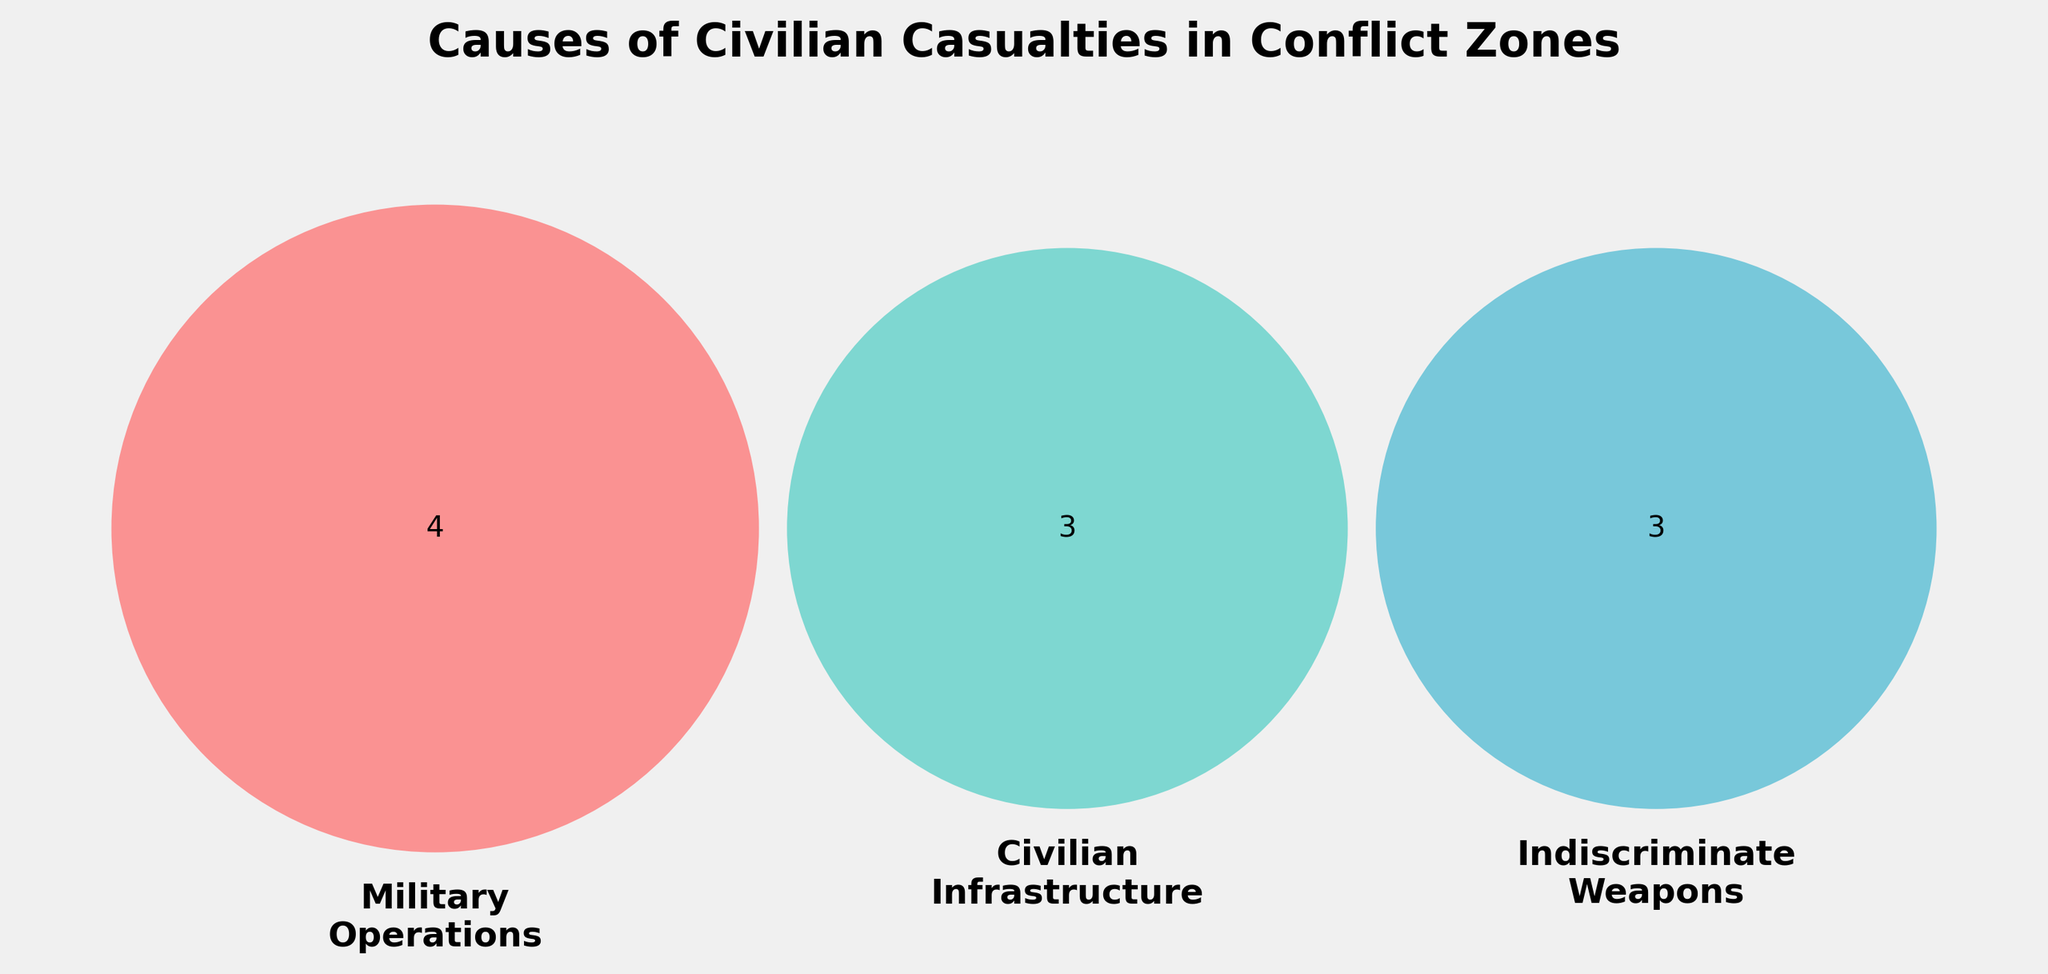What are the three categories represented in the Venn diagram? The Venn diagram shows three overlapping circles, each labeled with a category. Reading the labels, the categories are Military Operations, Civilian Infrastructure, and Indiscriminate Weapons.
Answer: Military Operations, Civilian Infrastructure, Indiscriminate Weapons Which color represents the Indiscriminate Weapons category? In the Venn diagram, the Indiscriminate Weapons category is represented by the circle filled with a blue color.
Answer: Blue How many causes of civilian casualties are unique to Military Operations? The segment of the Venn diagram representing only Military Operations shows the causes without any overlap with other categories. By counting, the number is four.
Answer: Four Which category has a cause labeled as "Drone attacks"? The label "Drone attacks" appears within the area corresponding to Military Operations in the Venn diagram.
Answer: Military Operations Are there any overlapping causes between Civilian Infrastructure and Indiscriminate Weapons? Reviewing the Venn diagram's segment where Civilian Infrastructure and Indiscriminate Weapons circles overlap, there are no causes listed, indicating no overlap.
Answer: No Which categories intersect where "Hospitals hit" is mentioned? The "Hospitals hit" label is found within the Civilian Infrastructure category part of the Venn diagram, with no overlap with other categories.
Answer: Civilian Infrastructure How many causes fall under the Indiscriminate Weapons category? By counting the individual sections within the Indiscriminate Weapons circle in the Venn diagram, a total of three causes are identified: Cluster munitions, Landmines, and Chemical weapons.
Answer: Three Do "Landmines" appear in the intersection of any categories? The "Landmines" cause is found in the portion of the Venn Diagram solely representing Indiscriminate Weapons, indicating no overlap with other categories.
Answer: No Which category has the most causes listed? Comparing the number of causes listed within each circle of the Venn diagram, Military Operations has the highest count at four.
Answer: Military Operations Does the Venn diagram show any common causes shared across all three categories? The central part of the Venn diagram, representing the intersection of all three categories, does not list any common causes.
Answer: No 